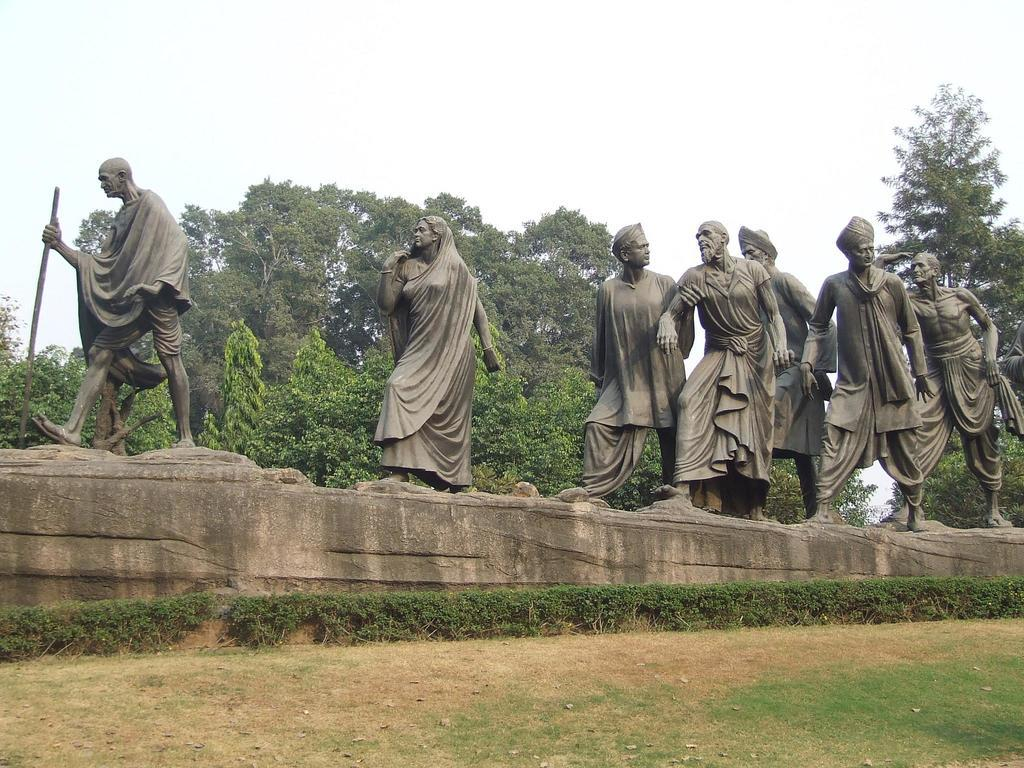What can be seen on the platform in the image? There are statues of persons on a platform. What type of vegetation is present on the ground? There is grass and plants on the ground. What can be seen in the background of the image? There are trees and the sky visible in the background. How many roses are being held by the statues in the image? There are no roses present in the image; the statues are not holding any flowers. What is the value of the statues in the image? The value of the statues cannot be determined from the image alone, as it depends on various factors such as the materials used, the artist, and the historical context. 